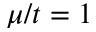<formula> <loc_0><loc_0><loc_500><loc_500>\mu / t = 1</formula> 